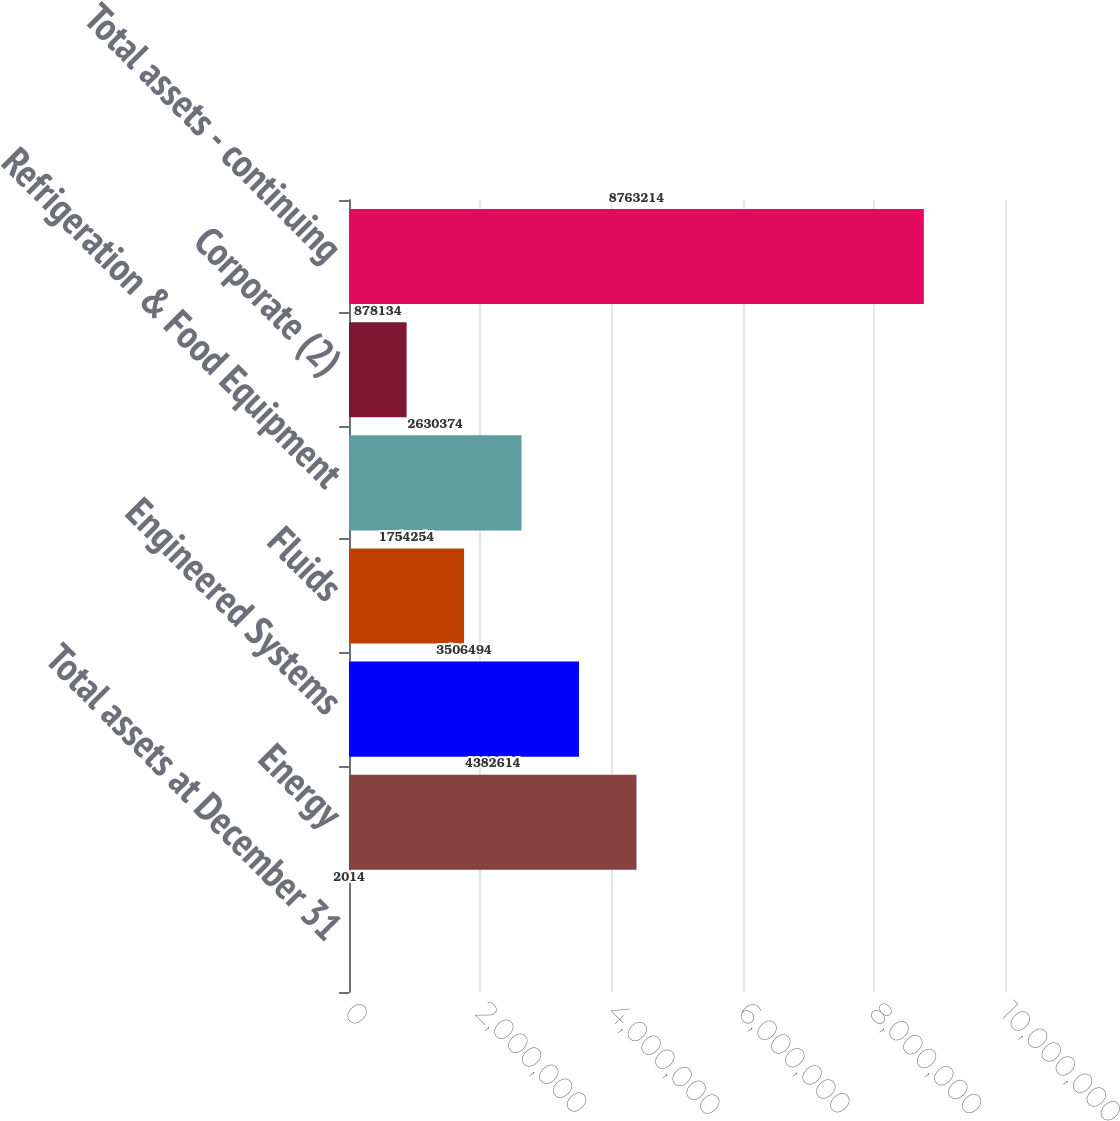Convert chart to OTSL. <chart><loc_0><loc_0><loc_500><loc_500><bar_chart><fcel>Total assets at December 31<fcel>Energy<fcel>Engineered Systems<fcel>Fluids<fcel>Refrigeration & Food Equipment<fcel>Corporate (2)<fcel>Total assets - continuing<nl><fcel>2014<fcel>4.38261e+06<fcel>3.50649e+06<fcel>1.75425e+06<fcel>2.63037e+06<fcel>878134<fcel>8.76321e+06<nl></chart> 